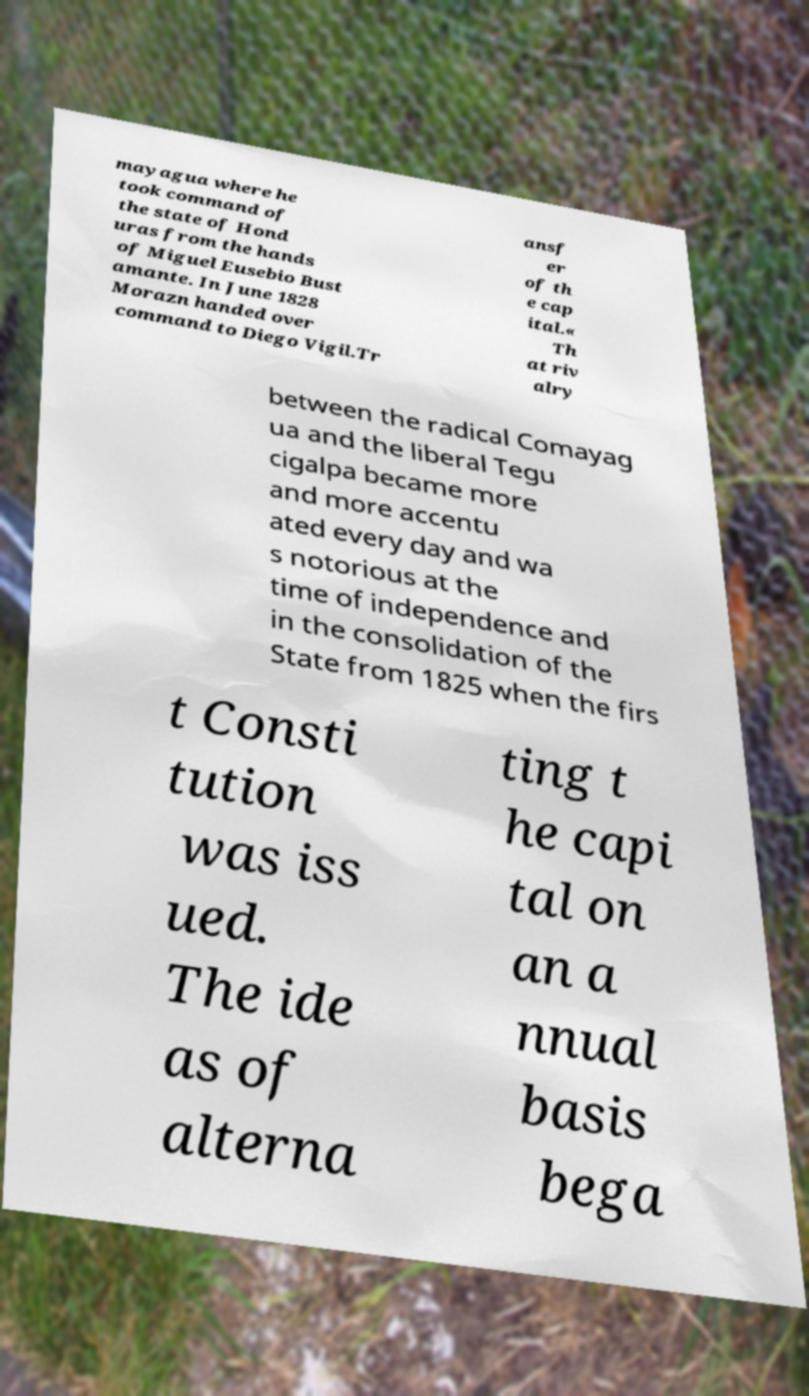I need the written content from this picture converted into text. Can you do that? mayagua where he took command of the state of Hond uras from the hands of Miguel Eusebio Bust amante. In June 1828 Morazn handed over command to Diego Vigil.Tr ansf er of th e cap ital.« Th at riv alry between the radical Comayag ua and the liberal Tegu cigalpa became more and more accentu ated every day and wa s notorious at the time of independence and in the consolidation of the State from 1825 when the firs t Consti tution was iss ued. The ide as of alterna ting t he capi tal on an a nnual basis bega 